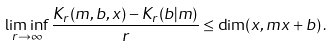<formula> <loc_0><loc_0><loc_500><loc_500>\liminf _ { r \to \infty } \frac { K _ { r } ( m , b , x ) - K _ { r } ( b | m ) } { r } \leq \dim ( x , m x + b ) \, .</formula> 